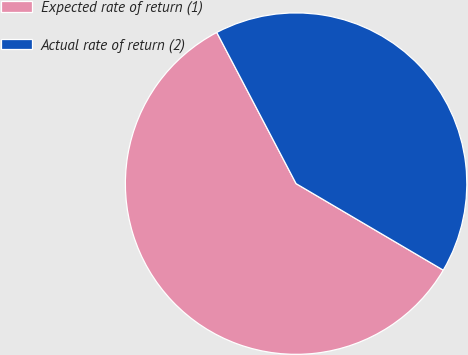<chart> <loc_0><loc_0><loc_500><loc_500><pie_chart><fcel>Expected rate of return (1)<fcel>Actual rate of return (2)<nl><fcel>58.85%<fcel>41.15%<nl></chart> 